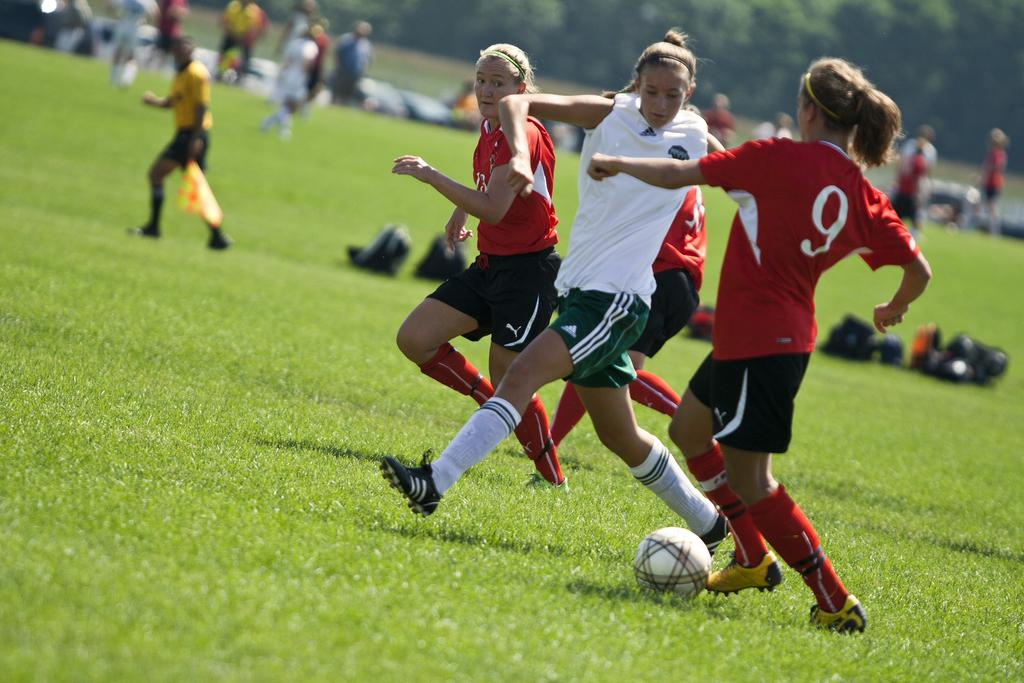<image>
Summarize the visual content of the image. Number 9 from the red team looks to get around an opponent in a white Adidas jersey 